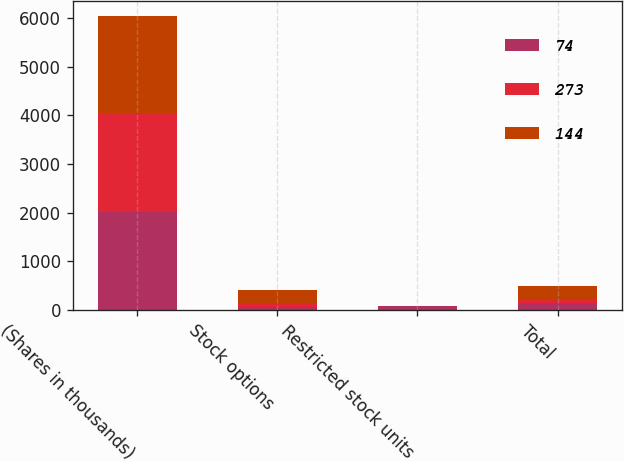<chart> <loc_0><loc_0><loc_500><loc_500><stacked_bar_chart><ecel><fcel>(Shares in thousands)<fcel>Stock options<fcel>Restricted stock units<fcel>Total<nl><fcel>74<fcel>2018<fcel>59<fcel>85<fcel>144<nl><fcel>273<fcel>2017<fcel>73<fcel>1<fcel>74<nl><fcel>144<fcel>2016<fcel>272<fcel>1<fcel>273<nl></chart> 